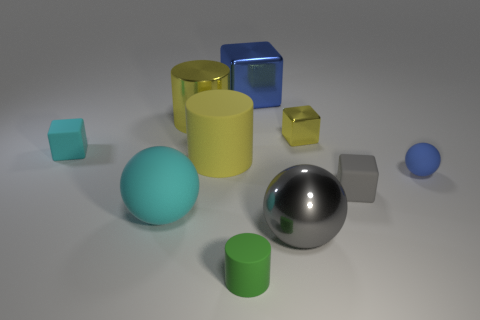Subtract all purple cubes. Subtract all red balls. How many cubes are left? 4 Subtract all balls. How many objects are left? 7 Subtract all small metallic things. Subtract all tiny metallic objects. How many objects are left? 8 Add 4 big matte things. How many big matte things are left? 6 Add 4 tiny blue rubber spheres. How many tiny blue rubber spheres exist? 5 Subtract 1 green cylinders. How many objects are left? 9 